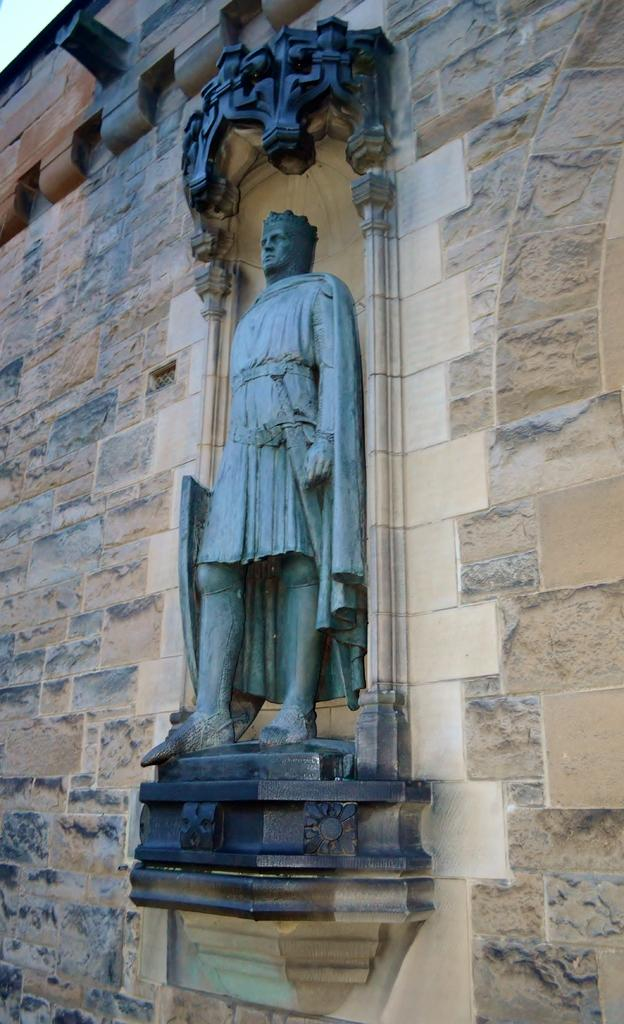What type of structure is depicted in the image? There is a wall of historical construction in the image. What can be seen on the wall? There is a sculpture of a man on the wall. Can you describe the sculpture? The sculpture has a design. What color are the wall and the sculpture? The wall and the sculpture are in black color. How many legs are visible on the hill in the image? There is no hill present in the image, and therefore no legs can be observed. 